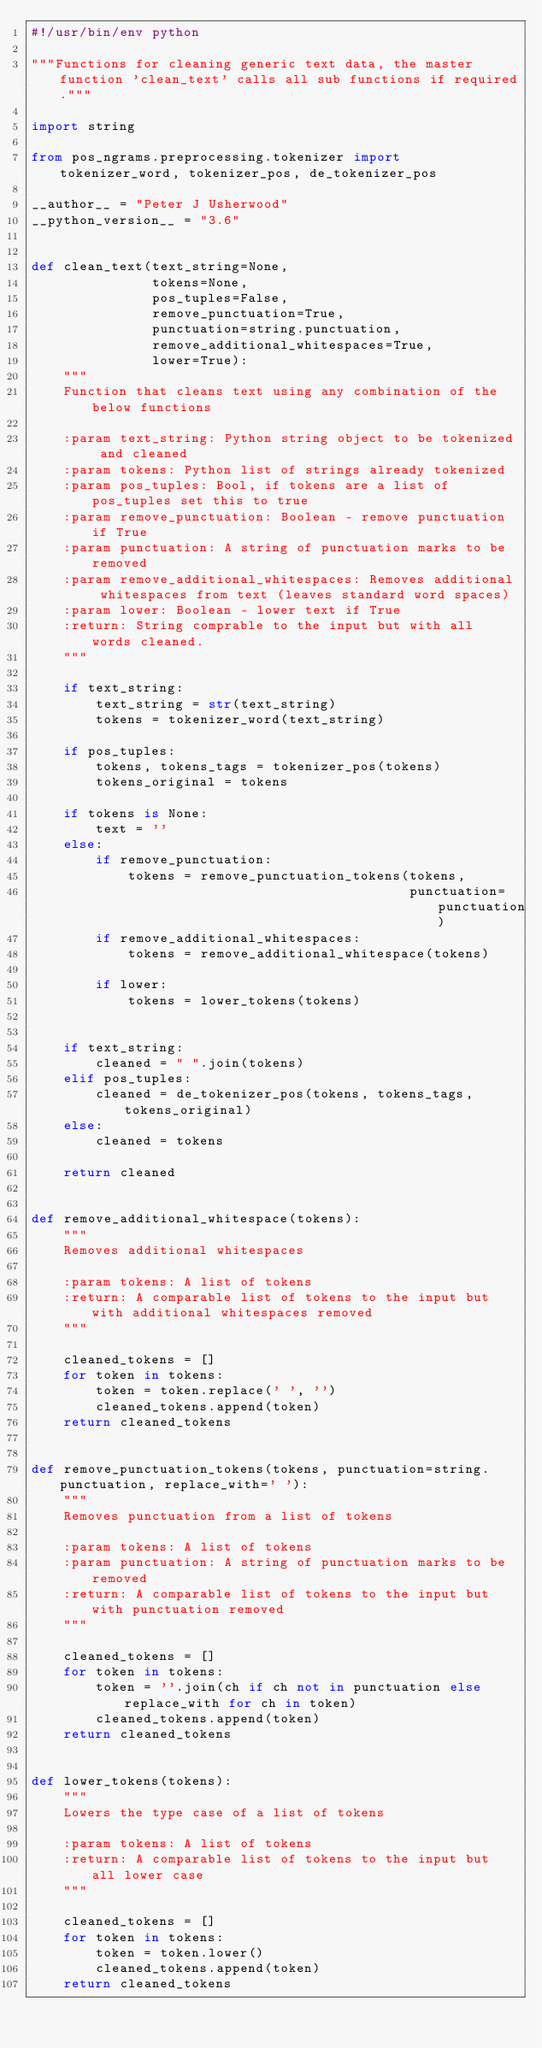Convert code to text. <code><loc_0><loc_0><loc_500><loc_500><_Python_>#!/usr/bin/env python

"""Functions for cleaning generic text data, the master function 'clean_text' calls all sub functions if required."""

import string

from pos_ngrams.preprocessing.tokenizer import tokenizer_word, tokenizer_pos, de_tokenizer_pos

__author__ = "Peter J Usherwood"
__python_version__ = "3.6"


def clean_text(text_string=None,
               tokens=None,
               pos_tuples=False,
               remove_punctuation=True,
               punctuation=string.punctuation,
               remove_additional_whitespaces=True,
               lower=True):
    """
    Function that cleans text using any combination of the below functions

    :param text_string: Python string object to be tokenized and cleaned
    :param tokens: Python list of strings already tokenized
    :param pos_tuples: Bool, if tokens are a list of pos_tuples set this to true
    :param remove_punctuation: Boolean - remove punctuation if True
    :param punctuation: A string of punctuation marks to be removed
    :param remove_additional_whitespaces: Removes additional whitespaces from text (leaves standard word spaces)
    :param lower: Boolean - lower text if True
    :return: String comprable to the input but with all words cleaned.
    """

    if text_string:
        text_string = str(text_string)
        tokens = tokenizer_word(text_string)

    if pos_tuples:
        tokens, tokens_tags = tokenizer_pos(tokens)
        tokens_original = tokens

    if tokens is None:
        text = ''
    else:
        if remove_punctuation:
            tokens = remove_punctuation_tokens(tokens,
                                               punctuation=punctuation)
        if remove_additional_whitespaces:
            tokens = remove_additional_whitespace(tokens)

        if lower:
            tokens = lower_tokens(tokens)


    if text_string:
        cleaned = " ".join(tokens)
    elif pos_tuples:
        cleaned = de_tokenizer_pos(tokens, tokens_tags, tokens_original)
    else:
        cleaned = tokens

    return cleaned


def remove_additional_whitespace(tokens):
    """
    Removes additional whitespaces

    :param tokens: A list of tokens
    :return: A comparable list of tokens to the input but with additional whitespaces removed
    """

    cleaned_tokens = []
    for token in tokens:
        token = token.replace(' ', '')
        cleaned_tokens.append(token)
    return cleaned_tokens


def remove_punctuation_tokens(tokens, punctuation=string.punctuation, replace_with=' '):
    """
    Removes punctuation from a list of tokens

    :param tokens: A list of tokens
    :param punctuation: A string of punctuation marks to be removed
    :return: A comparable list of tokens to the input but with punctuation removed
    """

    cleaned_tokens = []
    for token in tokens:
        token = ''.join(ch if ch not in punctuation else replace_with for ch in token)
        cleaned_tokens.append(token)
    return cleaned_tokens


def lower_tokens(tokens):
    """
    Lowers the type case of a list of tokens

    :param tokens: A list of tokens
    :return: A comparable list of tokens to the input but all lower case
    """

    cleaned_tokens = []
    for token in tokens:
        token = token.lower()
        cleaned_tokens.append(token)
    return cleaned_tokens
</code> 